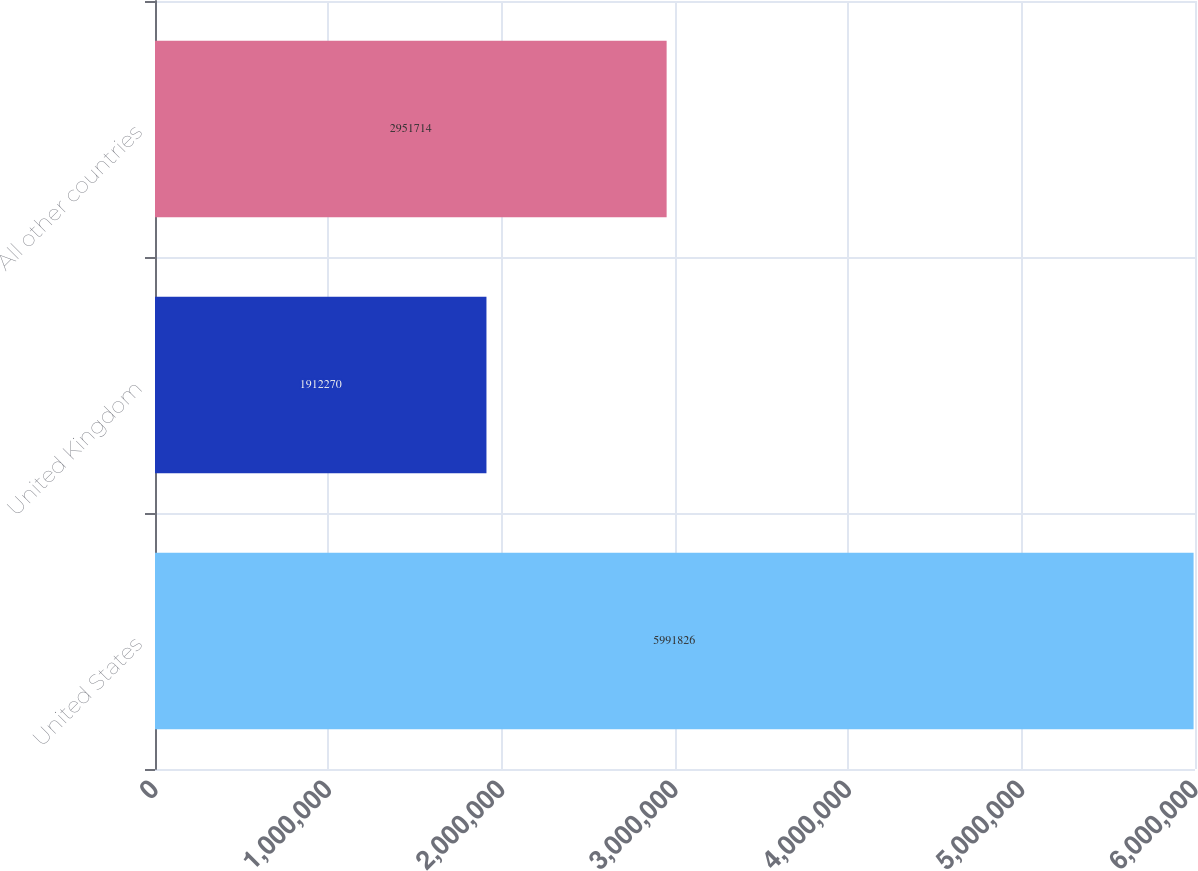Convert chart. <chart><loc_0><loc_0><loc_500><loc_500><bar_chart><fcel>United States<fcel>United Kingdom<fcel>All other countries<nl><fcel>5.99183e+06<fcel>1.91227e+06<fcel>2.95171e+06<nl></chart> 